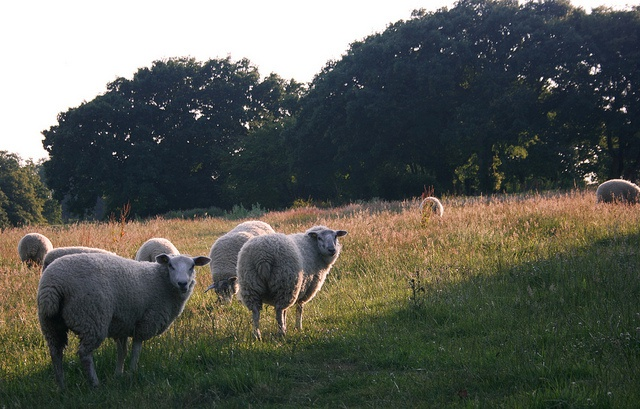Describe the objects in this image and their specific colors. I can see sheep in white, black, gray, and darkgray tones, sheep in white, gray, black, and darkgray tones, sheep in white, gray, darkgray, black, and lightgray tones, sheep in white, gray, darkgray, lightgray, and pink tones, and sheep in white, gray, black, and brown tones in this image. 